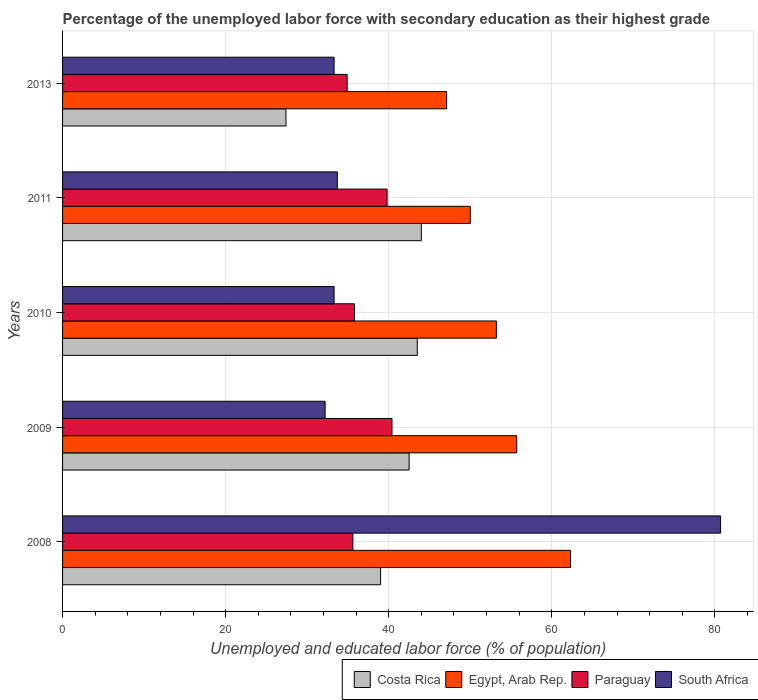How many different coloured bars are there?
Give a very brief answer. 4. How many groups of bars are there?
Offer a terse response. 5. Are the number of bars per tick equal to the number of legend labels?
Your answer should be very brief. Yes. Are the number of bars on each tick of the Y-axis equal?
Give a very brief answer. Yes. What is the label of the 4th group of bars from the top?
Offer a very short reply. 2009. What is the percentage of the unemployed labor force with secondary education in South Africa in 2011?
Give a very brief answer. 33.7. Across all years, what is the maximum percentage of the unemployed labor force with secondary education in Egypt, Arab Rep.?
Offer a terse response. 62.3. Across all years, what is the minimum percentage of the unemployed labor force with secondary education in Egypt, Arab Rep.?
Keep it short and to the point. 47.1. In which year was the percentage of the unemployed labor force with secondary education in Egypt, Arab Rep. maximum?
Offer a terse response. 2008. In which year was the percentage of the unemployed labor force with secondary education in South Africa minimum?
Provide a short and direct response. 2009. What is the total percentage of the unemployed labor force with secondary education in Egypt, Arab Rep. in the graph?
Make the answer very short. 268.3. What is the difference between the percentage of the unemployed labor force with secondary education in Paraguay in 2010 and the percentage of the unemployed labor force with secondary education in Egypt, Arab Rep. in 2011?
Your answer should be very brief. -14.2. What is the average percentage of the unemployed labor force with secondary education in Paraguay per year?
Your answer should be very brief. 37.3. In the year 2013, what is the difference between the percentage of the unemployed labor force with secondary education in Egypt, Arab Rep. and percentage of the unemployed labor force with secondary education in Costa Rica?
Your answer should be very brief. 19.7. In how many years, is the percentage of the unemployed labor force with secondary education in Costa Rica greater than 56 %?
Ensure brevity in your answer.  0. What is the ratio of the percentage of the unemployed labor force with secondary education in South Africa in 2008 to that in 2009?
Your answer should be compact. 2.51. What is the difference between the highest and the second highest percentage of the unemployed labor force with secondary education in South Africa?
Your response must be concise. 47. What is the difference between the highest and the lowest percentage of the unemployed labor force with secondary education in Egypt, Arab Rep.?
Offer a very short reply. 15.2. What does the 3rd bar from the top in 2009 represents?
Make the answer very short. Egypt, Arab Rep. What does the 3rd bar from the bottom in 2008 represents?
Provide a short and direct response. Paraguay. Is it the case that in every year, the sum of the percentage of the unemployed labor force with secondary education in Egypt, Arab Rep. and percentage of the unemployed labor force with secondary education in Paraguay is greater than the percentage of the unemployed labor force with secondary education in Costa Rica?
Your response must be concise. Yes. Does the graph contain grids?
Offer a terse response. Yes. How many legend labels are there?
Your response must be concise. 4. What is the title of the graph?
Your answer should be very brief. Percentage of the unemployed labor force with secondary education as their highest grade. What is the label or title of the X-axis?
Make the answer very short. Unemployed and educated labor force (% of population). What is the Unemployed and educated labor force (% of population) of Costa Rica in 2008?
Your answer should be compact. 39. What is the Unemployed and educated labor force (% of population) in Egypt, Arab Rep. in 2008?
Give a very brief answer. 62.3. What is the Unemployed and educated labor force (% of population) in Paraguay in 2008?
Your response must be concise. 35.6. What is the Unemployed and educated labor force (% of population) in South Africa in 2008?
Your answer should be very brief. 80.7. What is the Unemployed and educated labor force (% of population) of Costa Rica in 2009?
Your answer should be compact. 42.5. What is the Unemployed and educated labor force (% of population) of Egypt, Arab Rep. in 2009?
Your answer should be compact. 55.7. What is the Unemployed and educated labor force (% of population) of Paraguay in 2009?
Your answer should be very brief. 40.4. What is the Unemployed and educated labor force (% of population) of South Africa in 2009?
Your response must be concise. 32.2. What is the Unemployed and educated labor force (% of population) in Costa Rica in 2010?
Provide a succinct answer. 43.5. What is the Unemployed and educated labor force (% of population) in Egypt, Arab Rep. in 2010?
Ensure brevity in your answer.  53.2. What is the Unemployed and educated labor force (% of population) of Paraguay in 2010?
Your response must be concise. 35.8. What is the Unemployed and educated labor force (% of population) in South Africa in 2010?
Your response must be concise. 33.3. What is the Unemployed and educated labor force (% of population) of Egypt, Arab Rep. in 2011?
Provide a short and direct response. 50. What is the Unemployed and educated labor force (% of population) in Paraguay in 2011?
Your response must be concise. 39.8. What is the Unemployed and educated labor force (% of population) of South Africa in 2011?
Ensure brevity in your answer.  33.7. What is the Unemployed and educated labor force (% of population) in Costa Rica in 2013?
Keep it short and to the point. 27.4. What is the Unemployed and educated labor force (% of population) in Egypt, Arab Rep. in 2013?
Keep it short and to the point. 47.1. What is the Unemployed and educated labor force (% of population) of Paraguay in 2013?
Keep it short and to the point. 34.9. What is the Unemployed and educated labor force (% of population) in South Africa in 2013?
Your response must be concise. 33.3. Across all years, what is the maximum Unemployed and educated labor force (% of population) of Costa Rica?
Give a very brief answer. 44. Across all years, what is the maximum Unemployed and educated labor force (% of population) in Egypt, Arab Rep.?
Offer a very short reply. 62.3. Across all years, what is the maximum Unemployed and educated labor force (% of population) of Paraguay?
Keep it short and to the point. 40.4. Across all years, what is the maximum Unemployed and educated labor force (% of population) of South Africa?
Your response must be concise. 80.7. Across all years, what is the minimum Unemployed and educated labor force (% of population) of Costa Rica?
Your answer should be very brief. 27.4. Across all years, what is the minimum Unemployed and educated labor force (% of population) in Egypt, Arab Rep.?
Ensure brevity in your answer.  47.1. Across all years, what is the minimum Unemployed and educated labor force (% of population) of Paraguay?
Your answer should be compact. 34.9. Across all years, what is the minimum Unemployed and educated labor force (% of population) in South Africa?
Give a very brief answer. 32.2. What is the total Unemployed and educated labor force (% of population) in Costa Rica in the graph?
Offer a very short reply. 196.4. What is the total Unemployed and educated labor force (% of population) of Egypt, Arab Rep. in the graph?
Your answer should be compact. 268.3. What is the total Unemployed and educated labor force (% of population) of Paraguay in the graph?
Provide a succinct answer. 186.5. What is the total Unemployed and educated labor force (% of population) in South Africa in the graph?
Offer a very short reply. 213.2. What is the difference between the Unemployed and educated labor force (% of population) of Costa Rica in 2008 and that in 2009?
Ensure brevity in your answer.  -3.5. What is the difference between the Unemployed and educated labor force (% of population) in Egypt, Arab Rep. in 2008 and that in 2009?
Ensure brevity in your answer.  6.6. What is the difference between the Unemployed and educated labor force (% of population) of Paraguay in 2008 and that in 2009?
Make the answer very short. -4.8. What is the difference between the Unemployed and educated labor force (% of population) in South Africa in 2008 and that in 2009?
Your response must be concise. 48.5. What is the difference between the Unemployed and educated labor force (% of population) of Costa Rica in 2008 and that in 2010?
Give a very brief answer. -4.5. What is the difference between the Unemployed and educated labor force (% of population) in South Africa in 2008 and that in 2010?
Give a very brief answer. 47.4. What is the difference between the Unemployed and educated labor force (% of population) in Egypt, Arab Rep. in 2008 and that in 2011?
Ensure brevity in your answer.  12.3. What is the difference between the Unemployed and educated labor force (% of population) in South Africa in 2008 and that in 2011?
Offer a terse response. 47. What is the difference between the Unemployed and educated labor force (% of population) in South Africa in 2008 and that in 2013?
Your answer should be compact. 47.4. What is the difference between the Unemployed and educated labor force (% of population) in Egypt, Arab Rep. in 2009 and that in 2011?
Your answer should be very brief. 5.7. What is the difference between the Unemployed and educated labor force (% of population) of Paraguay in 2009 and that in 2011?
Provide a succinct answer. 0.6. What is the difference between the Unemployed and educated labor force (% of population) in South Africa in 2009 and that in 2011?
Your answer should be compact. -1.5. What is the difference between the Unemployed and educated labor force (% of population) of Costa Rica in 2009 and that in 2013?
Offer a terse response. 15.1. What is the difference between the Unemployed and educated labor force (% of population) of Egypt, Arab Rep. in 2009 and that in 2013?
Your answer should be very brief. 8.6. What is the difference between the Unemployed and educated labor force (% of population) in Paraguay in 2009 and that in 2013?
Give a very brief answer. 5.5. What is the difference between the Unemployed and educated labor force (% of population) of Paraguay in 2010 and that in 2011?
Ensure brevity in your answer.  -4. What is the difference between the Unemployed and educated labor force (% of population) of Egypt, Arab Rep. in 2010 and that in 2013?
Offer a very short reply. 6.1. What is the difference between the Unemployed and educated labor force (% of population) of South Africa in 2010 and that in 2013?
Your response must be concise. 0. What is the difference between the Unemployed and educated labor force (% of population) of Egypt, Arab Rep. in 2011 and that in 2013?
Offer a terse response. 2.9. What is the difference between the Unemployed and educated labor force (% of population) in Paraguay in 2011 and that in 2013?
Make the answer very short. 4.9. What is the difference between the Unemployed and educated labor force (% of population) in Costa Rica in 2008 and the Unemployed and educated labor force (% of population) in Egypt, Arab Rep. in 2009?
Offer a terse response. -16.7. What is the difference between the Unemployed and educated labor force (% of population) in Costa Rica in 2008 and the Unemployed and educated labor force (% of population) in Paraguay in 2009?
Give a very brief answer. -1.4. What is the difference between the Unemployed and educated labor force (% of population) in Egypt, Arab Rep. in 2008 and the Unemployed and educated labor force (% of population) in Paraguay in 2009?
Ensure brevity in your answer.  21.9. What is the difference between the Unemployed and educated labor force (% of population) in Egypt, Arab Rep. in 2008 and the Unemployed and educated labor force (% of population) in South Africa in 2009?
Your answer should be very brief. 30.1. What is the difference between the Unemployed and educated labor force (% of population) in Paraguay in 2008 and the Unemployed and educated labor force (% of population) in South Africa in 2009?
Offer a terse response. 3.4. What is the difference between the Unemployed and educated labor force (% of population) in Costa Rica in 2008 and the Unemployed and educated labor force (% of population) in Egypt, Arab Rep. in 2010?
Your response must be concise. -14.2. What is the difference between the Unemployed and educated labor force (% of population) of Costa Rica in 2008 and the Unemployed and educated labor force (% of population) of Paraguay in 2010?
Offer a very short reply. 3.2. What is the difference between the Unemployed and educated labor force (% of population) in Costa Rica in 2008 and the Unemployed and educated labor force (% of population) in South Africa in 2010?
Give a very brief answer. 5.7. What is the difference between the Unemployed and educated labor force (% of population) of Egypt, Arab Rep. in 2008 and the Unemployed and educated labor force (% of population) of Paraguay in 2010?
Your answer should be very brief. 26.5. What is the difference between the Unemployed and educated labor force (% of population) of Costa Rica in 2008 and the Unemployed and educated labor force (% of population) of Paraguay in 2011?
Make the answer very short. -0.8. What is the difference between the Unemployed and educated labor force (% of population) in Costa Rica in 2008 and the Unemployed and educated labor force (% of population) in South Africa in 2011?
Give a very brief answer. 5.3. What is the difference between the Unemployed and educated labor force (% of population) in Egypt, Arab Rep. in 2008 and the Unemployed and educated labor force (% of population) in South Africa in 2011?
Ensure brevity in your answer.  28.6. What is the difference between the Unemployed and educated labor force (% of population) of Costa Rica in 2008 and the Unemployed and educated labor force (% of population) of Egypt, Arab Rep. in 2013?
Offer a terse response. -8.1. What is the difference between the Unemployed and educated labor force (% of population) in Costa Rica in 2008 and the Unemployed and educated labor force (% of population) in Paraguay in 2013?
Give a very brief answer. 4.1. What is the difference between the Unemployed and educated labor force (% of population) in Egypt, Arab Rep. in 2008 and the Unemployed and educated labor force (% of population) in Paraguay in 2013?
Make the answer very short. 27.4. What is the difference between the Unemployed and educated labor force (% of population) in Egypt, Arab Rep. in 2008 and the Unemployed and educated labor force (% of population) in South Africa in 2013?
Offer a very short reply. 29. What is the difference between the Unemployed and educated labor force (% of population) in Costa Rica in 2009 and the Unemployed and educated labor force (% of population) in Egypt, Arab Rep. in 2010?
Give a very brief answer. -10.7. What is the difference between the Unemployed and educated labor force (% of population) in Costa Rica in 2009 and the Unemployed and educated labor force (% of population) in Paraguay in 2010?
Give a very brief answer. 6.7. What is the difference between the Unemployed and educated labor force (% of population) of Costa Rica in 2009 and the Unemployed and educated labor force (% of population) of South Africa in 2010?
Your answer should be very brief. 9.2. What is the difference between the Unemployed and educated labor force (% of population) in Egypt, Arab Rep. in 2009 and the Unemployed and educated labor force (% of population) in Paraguay in 2010?
Your answer should be very brief. 19.9. What is the difference between the Unemployed and educated labor force (% of population) of Egypt, Arab Rep. in 2009 and the Unemployed and educated labor force (% of population) of South Africa in 2010?
Offer a terse response. 22.4. What is the difference between the Unemployed and educated labor force (% of population) in Paraguay in 2009 and the Unemployed and educated labor force (% of population) in South Africa in 2010?
Your response must be concise. 7.1. What is the difference between the Unemployed and educated labor force (% of population) in Costa Rica in 2009 and the Unemployed and educated labor force (% of population) in South Africa in 2011?
Keep it short and to the point. 8.8. What is the difference between the Unemployed and educated labor force (% of population) in Egypt, Arab Rep. in 2009 and the Unemployed and educated labor force (% of population) in South Africa in 2011?
Your response must be concise. 22. What is the difference between the Unemployed and educated labor force (% of population) of Paraguay in 2009 and the Unemployed and educated labor force (% of population) of South Africa in 2011?
Ensure brevity in your answer.  6.7. What is the difference between the Unemployed and educated labor force (% of population) of Costa Rica in 2009 and the Unemployed and educated labor force (% of population) of Paraguay in 2013?
Offer a terse response. 7.6. What is the difference between the Unemployed and educated labor force (% of population) of Egypt, Arab Rep. in 2009 and the Unemployed and educated labor force (% of population) of Paraguay in 2013?
Make the answer very short. 20.8. What is the difference between the Unemployed and educated labor force (% of population) in Egypt, Arab Rep. in 2009 and the Unemployed and educated labor force (% of population) in South Africa in 2013?
Your answer should be very brief. 22.4. What is the difference between the Unemployed and educated labor force (% of population) in Paraguay in 2010 and the Unemployed and educated labor force (% of population) in South Africa in 2011?
Your answer should be very brief. 2.1. What is the difference between the Unemployed and educated labor force (% of population) of Costa Rica in 2010 and the Unemployed and educated labor force (% of population) of South Africa in 2013?
Provide a succinct answer. 10.2. What is the difference between the Unemployed and educated labor force (% of population) of Egypt, Arab Rep. in 2010 and the Unemployed and educated labor force (% of population) of Paraguay in 2013?
Give a very brief answer. 18.3. What is the difference between the Unemployed and educated labor force (% of population) in Paraguay in 2010 and the Unemployed and educated labor force (% of population) in South Africa in 2013?
Your answer should be compact. 2.5. What is the difference between the Unemployed and educated labor force (% of population) of Costa Rica in 2011 and the Unemployed and educated labor force (% of population) of Egypt, Arab Rep. in 2013?
Your response must be concise. -3.1. What is the difference between the Unemployed and educated labor force (% of population) in Costa Rica in 2011 and the Unemployed and educated labor force (% of population) in Paraguay in 2013?
Provide a succinct answer. 9.1. What is the difference between the Unemployed and educated labor force (% of population) of Paraguay in 2011 and the Unemployed and educated labor force (% of population) of South Africa in 2013?
Provide a short and direct response. 6.5. What is the average Unemployed and educated labor force (% of population) in Costa Rica per year?
Keep it short and to the point. 39.28. What is the average Unemployed and educated labor force (% of population) of Egypt, Arab Rep. per year?
Offer a very short reply. 53.66. What is the average Unemployed and educated labor force (% of population) in Paraguay per year?
Offer a very short reply. 37.3. What is the average Unemployed and educated labor force (% of population) in South Africa per year?
Your response must be concise. 42.64. In the year 2008, what is the difference between the Unemployed and educated labor force (% of population) of Costa Rica and Unemployed and educated labor force (% of population) of Egypt, Arab Rep.?
Your answer should be very brief. -23.3. In the year 2008, what is the difference between the Unemployed and educated labor force (% of population) in Costa Rica and Unemployed and educated labor force (% of population) in Paraguay?
Offer a very short reply. 3.4. In the year 2008, what is the difference between the Unemployed and educated labor force (% of population) of Costa Rica and Unemployed and educated labor force (% of population) of South Africa?
Your answer should be very brief. -41.7. In the year 2008, what is the difference between the Unemployed and educated labor force (% of population) in Egypt, Arab Rep. and Unemployed and educated labor force (% of population) in Paraguay?
Your response must be concise. 26.7. In the year 2008, what is the difference between the Unemployed and educated labor force (% of population) in Egypt, Arab Rep. and Unemployed and educated labor force (% of population) in South Africa?
Keep it short and to the point. -18.4. In the year 2008, what is the difference between the Unemployed and educated labor force (% of population) of Paraguay and Unemployed and educated labor force (% of population) of South Africa?
Give a very brief answer. -45.1. In the year 2009, what is the difference between the Unemployed and educated labor force (% of population) of Costa Rica and Unemployed and educated labor force (% of population) of Egypt, Arab Rep.?
Keep it short and to the point. -13.2. In the year 2009, what is the difference between the Unemployed and educated labor force (% of population) in Costa Rica and Unemployed and educated labor force (% of population) in Paraguay?
Make the answer very short. 2.1. In the year 2009, what is the difference between the Unemployed and educated labor force (% of population) of Egypt, Arab Rep. and Unemployed and educated labor force (% of population) of Paraguay?
Offer a very short reply. 15.3. In the year 2009, what is the difference between the Unemployed and educated labor force (% of population) in Paraguay and Unemployed and educated labor force (% of population) in South Africa?
Give a very brief answer. 8.2. In the year 2010, what is the difference between the Unemployed and educated labor force (% of population) in Costa Rica and Unemployed and educated labor force (% of population) in South Africa?
Offer a terse response. 10.2. In the year 2010, what is the difference between the Unemployed and educated labor force (% of population) in Egypt, Arab Rep. and Unemployed and educated labor force (% of population) in South Africa?
Offer a very short reply. 19.9. In the year 2010, what is the difference between the Unemployed and educated labor force (% of population) in Paraguay and Unemployed and educated labor force (% of population) in South Africa?
Offer a terse response. 2.5. In the year 2011, what is the difference between the Unemployed and educated labor force (% of population) of Egypt, Arab Rep. and Unemployed and educated labor force (% of population) of South Africa?
Provide a succinct answer. 16.3. In the year 2011, what is the difference between the Unemployed and educated labor force (% of population) of Paraguay and Unemployed and educated labor force (% of population) of South Africa?
Ensure brevity in your answer.  6.1. In the year 2013, what is the difference between the Unemployed and educated labor force (% of population) of Costa Rica and Unemployed and educated labor force (% of population) of Egypt, Arab Rep.?
Offer a terse response. -19.7. In the year 2013, what is the difference between the Unemployed and educated labor force (% of population) in Costa Rica and Unemployed and educated labor force (% of population) in Paraguay?
Provide a succinct answer. -7.5. In the year 2013, what is the difference between the Unemployed and educated labor force (% of population) of Costa Rica and Unemployed and educated labor force (% of population) of South Africa?
Provide a short and direct response. -5.9. What is the ratio of the Unemployed and educated labor force (% of population) in Costa Rica in 2008 to that in 2009?
Your answer should be compact. 0.92. What is the ratio of the Unemployed and educated labor force (% of population) in Egypt, Arab Rep. in 2008 to that in 2009?
Your answer should be very brief. 1.12. What is the ratio of the Unemployed and educated labor force (% of population) of Paraguay in 2008 to that in 2009?
Keep it short and to the point. 0.88. What is the ratio of the Unemployed and educated labor force (% of population) of South Africa in 2008 to that in 2009?
Your answer should be very brief. 2.51. What is the ratio of the Unemployed and educated labor force (% of population) of Costa Rica in 2008 to that in 2010?
Ensure brevity in your answer.  0.9. What is the ratio of the Unemployed and educated labor force (% of population) of Egypt, Arab Rep. in 2008 to that in 2010?
Give a very brief answer. 1.17. What is the ratio of the Unemployed and educated labor force (% of population) in South Africa in 2008 to that in 2010?
Ensure brevity in your answer.  2.42. What is the ratio of the Unemployed and educated labor force (% of population) in Costa Rica in 2008 to that in 2011?
Provide a succinct answer. 0.89. What is the ratio of the Unemployed and educated labor force (% of population) of Egypt, Arab Rep. in 2008 to that in 2011?
Offer a terse response. 1.25. What is the ratio of the Unemployed and educated labor force (% of population) of Paraguay in 2008 to that in 2011?
Provide a short and direct response. 0.89. What is the ratio of the Unemployed and educated labor force (% of population) in South Africa in 2008 to that in 2011?
Your answer should be very brief. 2.39. What is the ratio of the Unemployed and educated labor force (% of population) of Costa Rica in 2008 to that in 2013?
Your response must be concise. 1.42. What is the ratio of the Unemployed and educated labor force (% of population) in Egypt, Arab Rep. in 2008 to that in 2013?
Give a very brief answer. 1.32. What is the ratio of the Unemployed and educated labor force (% of population) in Paraguay in 2008 to that in 2013?
Ensure brevity in your answer.  1.02. What is the ratio of the Unemployed and educated labor force (% of population) of South Africa in 2008 to that in 2013?
Offer a very short reply. 2.42. What is the ratio of the Unemployed and educated labor force (% of population) of Egypt, Arab Rep. in 2009 to that in 2010?
Ensure brevity in your answer.  1.05. What is the ratio of the Unemployed and educated labor force (% of population) of Paraguay in 2009 to that in 2010?
Your answer should be compact. 1.13. What is the ratio of the Unemployed and educated labor force (% of population) in Costa Rica in 2009 to that in 2011?
Your response must be concise. 0.97. What is the ratio of the Unemployed and educated labor force (% of population) of Egypt, Arab Rep. in 2009 to that in 2011?
Ensure brevity in your answer.  1.11. What is the ratio of the Unemployed and educated labor force (% of population) of Paraguay in 2009 to that in 2011?
Offer a terse response. 1.02. What is the ratio of the Unemployed and educated labor force (% of population) in South Africa in 2009 to that in 2011?
Offer a terse response. 0.96. What is the ratio of the Unemployed and educated labor force (% of population) in Costa Rica in 2009 to that in 2013?
Provide a short and direct response. 1.55. What is the ratio of the Unemployed and educated labor force (% of population) of Egypt, Arab Rep. in 2009 to that in 2013?
Offer a very short reply. 1.18. What is the ratio of the Unemployed and educated labor force (% of population) of Paraguay in 2009 to that in 2013?
Your response must be concise. 1.16. What is the ratio of the Unemployed and educated labor force (% of population) in Egypt, Arab Rep. in 2010 to that in 2011?
Make the answer very short. 1.06. What is the ratio of the Unemployed and educated labor force (% of population) of Paraguay in 2010 to that in 2011?
Your response must be concise. 0.9. What is the ratio of the Unemployed and educated labor force (% of population) of Costa Rica in 2010 to that in 2013?
Your answer should be compact. 1.59. What is the ratio of the Unemployed and educated labor force (% of population) in Egypt, Arab Rep. in 2010 to that in 2013?
Your answer should be compact. 1.13. What is the ratio of the Unemployed and educated labor force (% of population) in Paraguay in 2010 to that in 2013?
Provide a succinct answer. 1.03. What is the ratio of the Unemployed and educated labor force (% of population) in Costa Rica in 2011 to that in 2013?
Provide a succinct answer. 1.61. What is the ratio of the Unemployed and educated labor force (% of population) of Egypt, Arab Rep. in 2011 to that in 2013?
Keep it short and to the point. 1.06. What is the ratio of the Unemployed and educated labor force (% of population) of Paraguay in 2011 to that in 2013?
Offer a very short reply. 1.14. What is the ratio of the Unemployed and educated labor force (% of population) in South Africa in 2011 to that in 2013?
Ensure brevity in your answer.  1.01. What is the difference between the highest and the second highest Unemployed and educated labor force (% of population) of Costa Rica?
Provide a short and direct response. 0.5. What is the difference between the highest and the second highest Unemployed and educated labor force (% of population) in Egypt, Arab Rep.?
Make the answer very short. 6.6. What is the difference between the highest and the second highest Unemployed and educated labor force (% of population) of Paraguay?
Provide a short and direct response. 0.6. What is the difference between the highest and the lowest Unemployed and educated labor force (% of population) of Costa Rica?
Make the answer very short. 16.6. What is the difference between the highest and the lowest Unemployed and educated labor force (% of population) in Egypt, Arab Rep.?
Make the answer very short. 15.2. What is the difference between the highest and the lowest Unemployed and educated labor force (% of population) of South Africa?
Your answer should be compact. 48.5. 